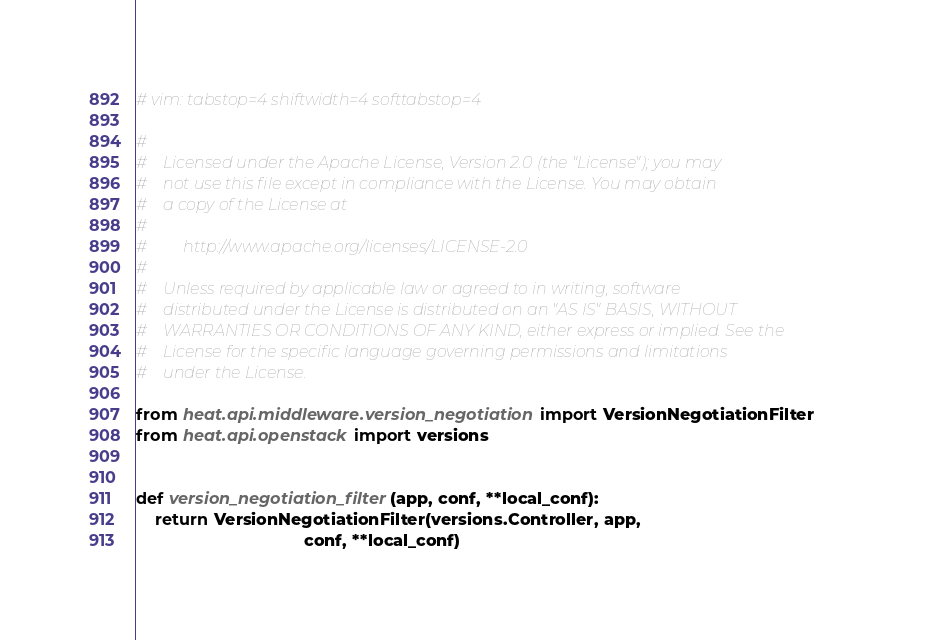<code> <loc_0><loc_0><loc_500><loc_500><_Python_># vim: tabstop=4 shiftwidth=4 softtabstop=4

#
#    Licensed under the Apache License, Version 2.0 (the "License"); you may
#    not use this file except in compliance with the License. You may obtain
#    a copy of the License at
#
#         http://www.apache.org/licenses/LICENSE-2.0
#
#    Unless required by applicable law or agreed to in writing, software
#    distributed under the License is distributed on an "AS IS" BASIS, WITHOUT
#    WARRANTIES OR CONDITIONS OF ANY KIND, either express or implied. See the
#    License for the specific language governing permissions and limitations
#    under the License.

from heat.api.middleware.version_negotiation import VersionNegotiationFilter
from heat.api.openstack import versions


def version_negotiation_filter(app, conf, **local_conf):
    return VersionNegotiationFilter(versions.Controller, app,
                                    conf, **local_conf)
</code> 